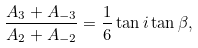Convert formula to latex. <formula><loc_0><loc_0><loc_500><loc_500>\frac { A _ { 3 } + A _ { - 3 } } { A _ { 2 } + A _ { - 2 } } = \frac { 1 } { 6 } \tan i \tan \beta ,</formula> 